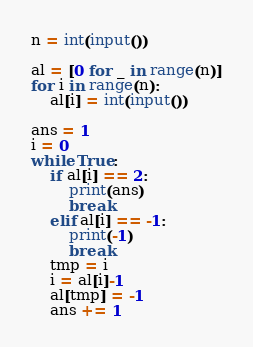Convert code to text. <code><loc_0><loc_0><loc_500><loc_500><_Python_>n = int(input())

al = [0 for _ in range(n)]
for i in range(n):
    al[i] = int(input())

ans = 1
i = 0
while True:
    if al[i] == 2:
        print(ans)
        break
    elif al[i] == -1:
        print(-1)
        break
    tmp = i
    i = al[i]-1
    al[tmp] = -1
    ans += 1
</code> 